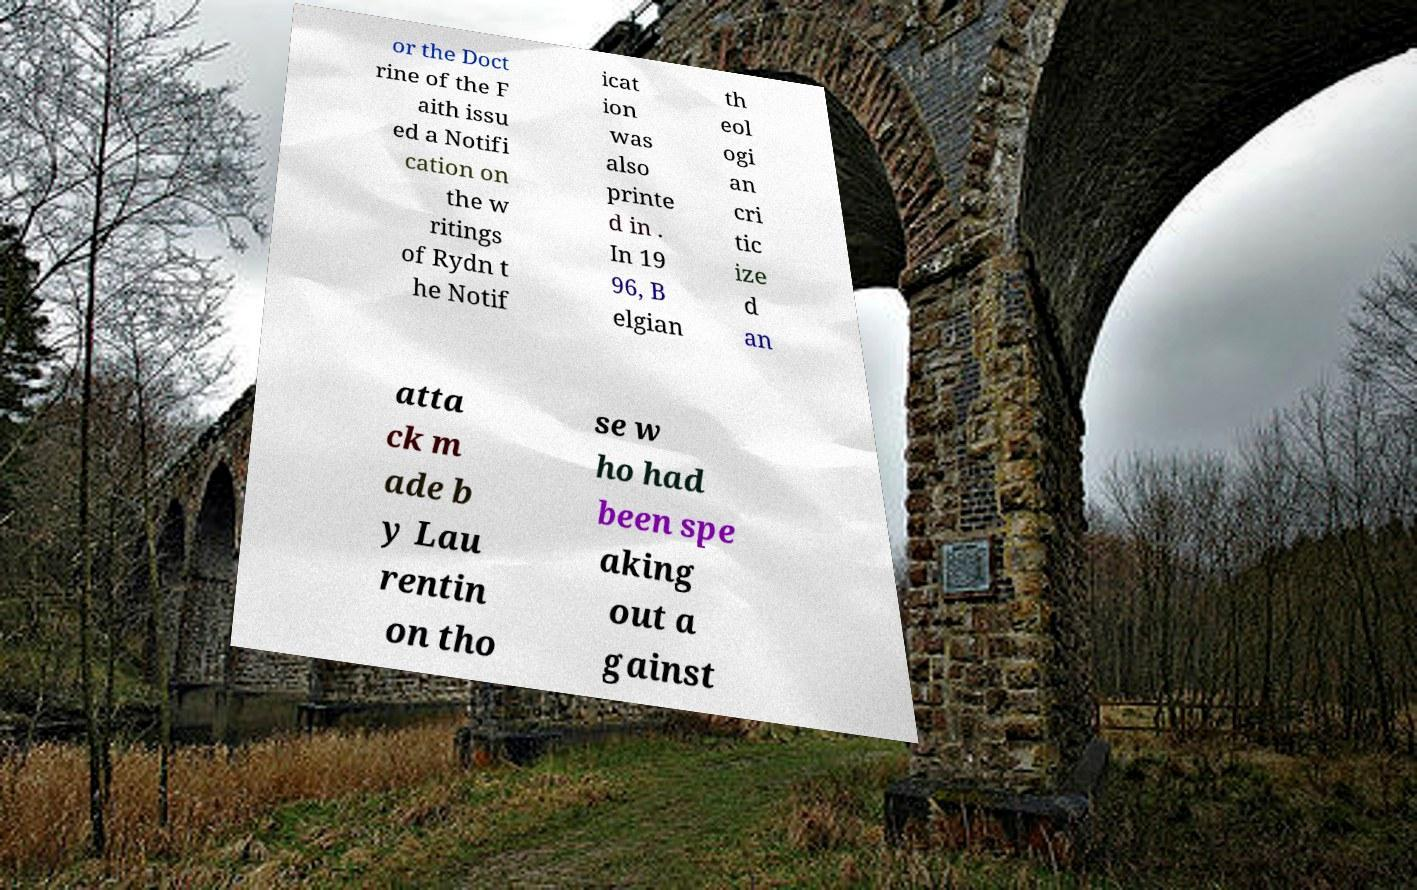Can you accurately transcribe the text from the provided image for me? or the Doct rine of the F aith issu ed a Notifi cation on the w ritings of Rydn t he Notif icat ion was also printe d in . In 19 96, B elgian th eol ogi an cri tic ize d an atta ck m ade b y Lau rentin on tho se w ho had been spe aking out a gainst 